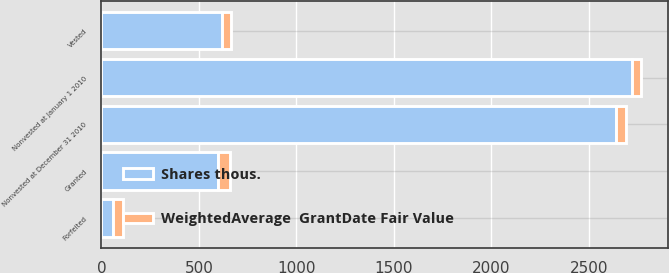<chart> <loc_0><loc_0><loc_500><loc_500><stacked_bar_chart><ecel><fcel>Nonvested at January 1 2010<fcel>Granted<fcel>Vested<fcel>Forfeited<fcel>Nonvested at December 31 2010<nl><fcel>Shares thous.<fcel>2719<fcel>598<fcel>620<fcel>59<fcel>2638<nl><fcel>WeightedAverage  GrantDate Fair Value<fcel>50.13<fcel>61.01<fcel>43.76<fcel>53.87<fcel>54.01<nl></chart> 